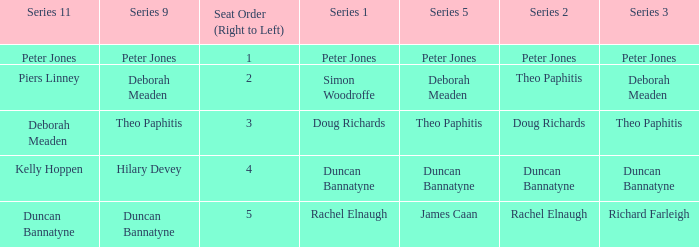Which Series 2 has a Series 3 of deborah meaden? Theo Paphitis. 